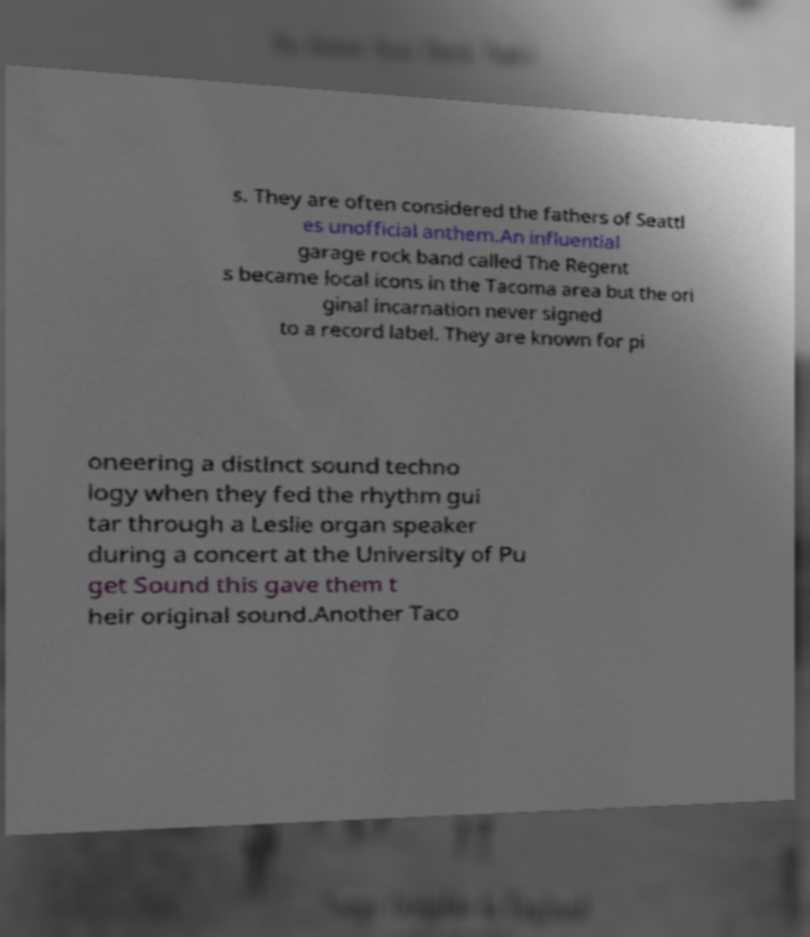Can you read and provide the text displayed in the image?This photo seems to have some interesting text. Can you extract and type it out for me? s. They are often considered the fathers of Seattl es unofficial anthem.An influential garage rock band called The Regent s became local icons in the Tacoma area but the ori ginal incarnation never signed to a record label. They are known for pi oneering a distinct sound techno logy when they fed the rhythm gui tar through a Leslie organ speaker during a concert at the University of Pu get Sound this gave them t heir original sound.Another Taco 